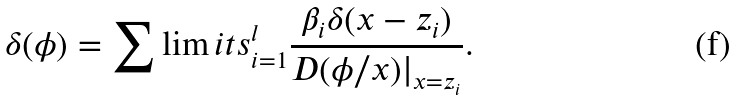Convert formula to latex. <formula><loc_0><loc_0><loc_500><loc_500>\delta ( \phi ) = \sum \lim i t s _ { i = 1 } ^ { l } \frac { \beta _ { i } \delta ( x - z _ { i } ) } { D ( \phi / x ) | _ { x = z _ { i } } } .</formula> 